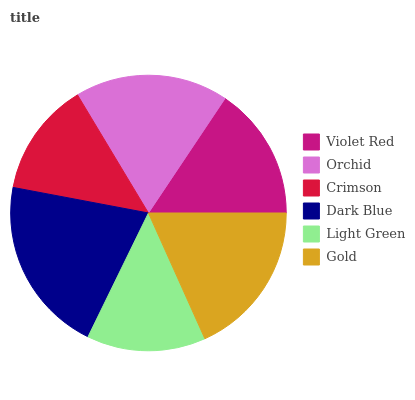Is Crimson the minimum?
Answer yes or no. Yes. Is Dark Blue the maximum?
Answer yes or no. Yes. Is Orchid the minimum?
Answer yes or no. No. Is Orchid the maximum?
Answer yes or no. No. Is Orchid greater than Violet Red?
Answer yes or no. Yes. Is Violet Red less than Orchid?
Answer yes or no. Yes. Is Violet Red greater than Orchid?
Answer yes or no. No. Is Orchid less than Violet Red?
Answer yes or no. No. Is Orchid the high median?
Answer yes or no. Yes. Is Violet Red the low median?
Answer yes or no. Yes. Is Violet Red the high median?
Answer yes or no. No. Is Orchid the low median?
Answer yes or no. No. 